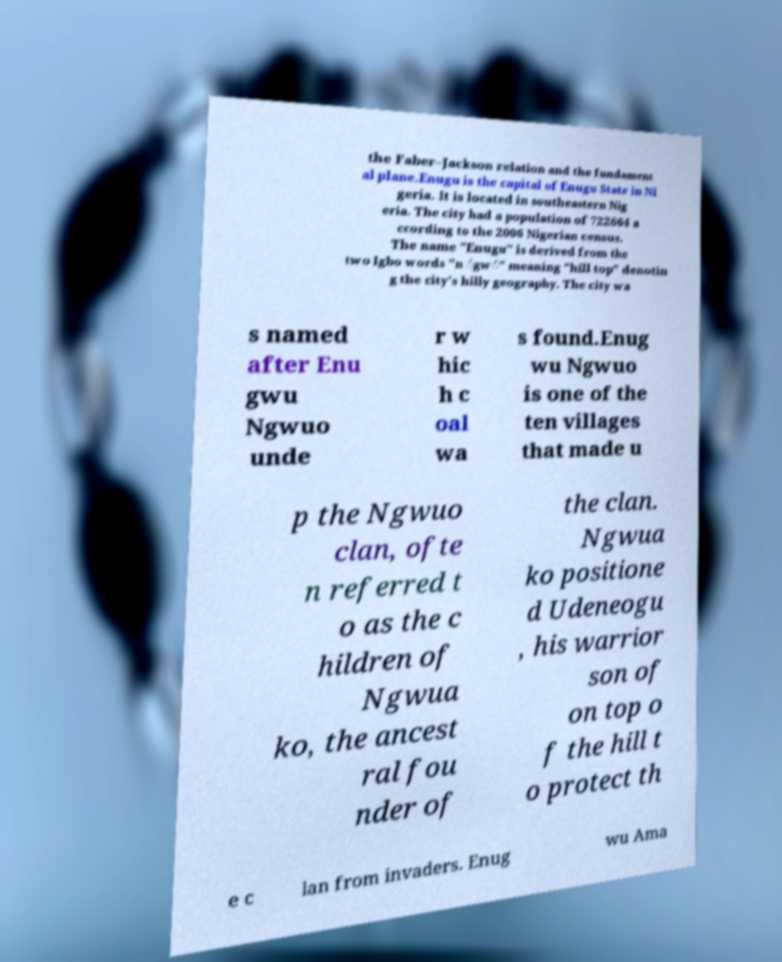What messages or text are displayed in this image? I need them in a readable, typed format. the Faber–Jackson relation and the fundament al plane.Enugu is the capital of Enugu State in Ni geria. It is located in southeastern Nig eria. The city had a population of 722664 a ccording to the 2006 Nigerian census. The name "Enugu" is derived from the two Igbo words "n ́gẃ" meaning "hill top" denotin g the city's hilly geography. The city wa s named after Enu gwu Ngwuo unde r w hic h c oal wa s found.Enug wu Ngwuo is one of the ten villages that made u p the Ngwuo clan, ofte n referred t o as the c hildren of Ngwua ko, the ancest ral fou nder of the clan. Ngwua ko positione d Udeneogu , his warrior son of on top o f the hill t o protect th e c lan from invaders. Enug wu Ama 